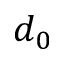<formula> <loc_0><loc_0><loc_500><loc_500>d _ { 0 }</formula> 